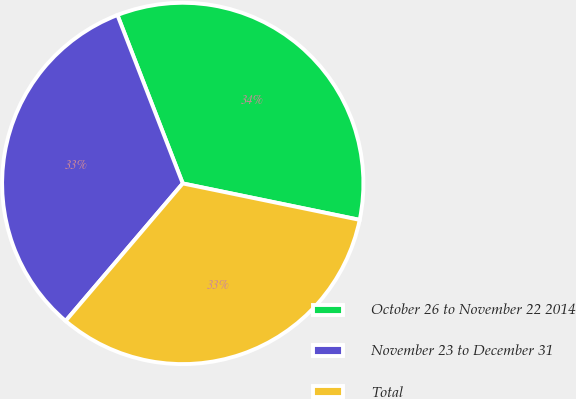Convert chart to OTSL. <chart><loc_0><loc_0><loc_500><loc_500><pie_chart><fcel>October 26 to November 22 2014<fcel>November 23 to December 31<fcel>Total<nl><fcel>34.12%<fcel>32.88%<fcel>33.0%<nl></chart> 